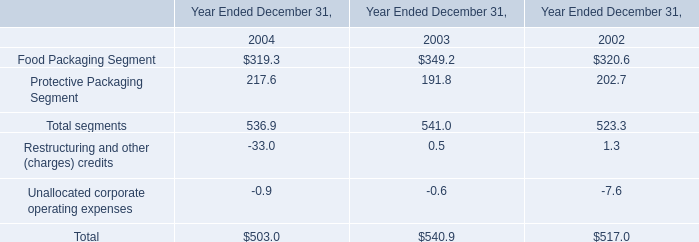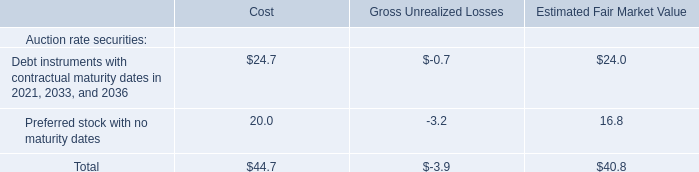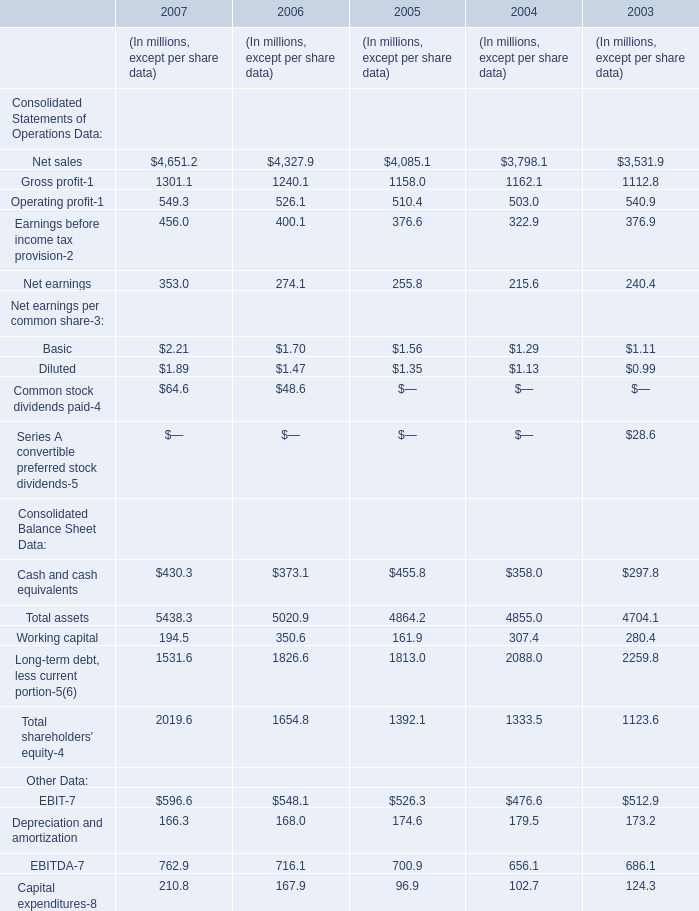In the year with lowest amount of Food Packaging Segment, what's the increasing rate of Net sales for Consolidated Statements of Operations Data? 
Computations: ((4085.1 - 3798.1) / 3798.1)
Answer: 0.07556. 